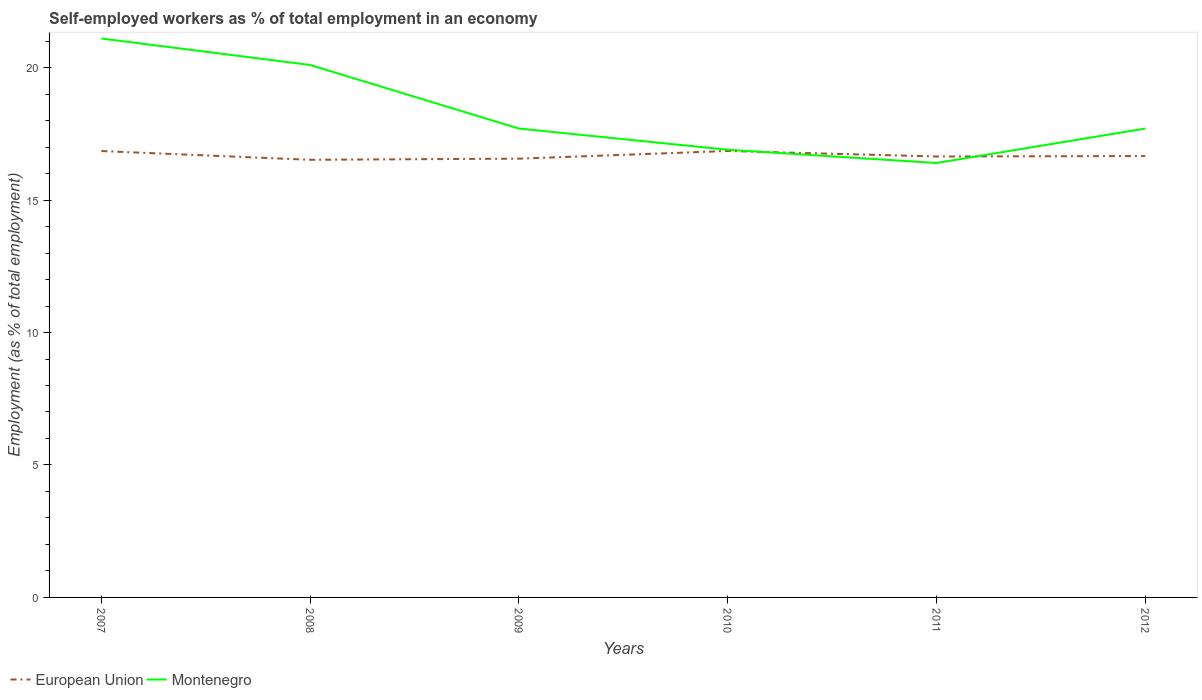Across all years, what is the maximum percentage of self-employed workers in Montenegro?
Your answer should be very brief. 16.4. In which year was the percentage of self-employed workers in European Union maximum?
Your response must be concise. 2008. What is the total percentage of self-employed workers in Montenegro in the graph?
Give a very brief answer. 2.4. What is the difference between the highest and the second highest percentage of self-employed workers in Montenegro?
Ensure brevity in your answer.  4.7. Is the percentage of self-employed workers in European Union strictly greater than the percentage of self-employed workers in Montenegro over the years?
Offer a very short reply. No. How many lines are there?
Offer a very short reply. 2. What is the difference between two consecutive major ticks on the Y-axis?
Make the answer very short. 5. Does the graph contain grids?
Your answer should be compact. No. How many legend labels are there?
Keep it short and to the point. 2. How are the legend labels stacked?
Provide a succinct answer. Horizontal. What is the title of the graph?
Keep it short and to the point. Self-employed workers as % of total employment in an economy. Does "Swaziland" appear as one of the legend labels in the graph?
Make the answer very short. No. What is the label or title of the X-axis?
Your answer should be compact. Years. What is the label or title of the Y-axis?
Your answer should be compact. Employment (as % of total employment). What is the Employment (as % of total employment) in European Union in 2007?
Your answer should be very brief. 16.85. What is the Employment (as % of total employment) in Montenegro in 2007?
Provide a short and direct response. 21.1. What is the Employment (as % of total employment) of European Union in 2008?
Your answer should be very brief. 16.52. What is the Employment (as % of total employment) of Montenegro in 2008?
Offer a very short reply. 20.1. What is the Employment (as % of total employment) of European Union in 2009?
Provide a succinct answer. 16.56. What is the Employment (as % of total employment) of Montenegro in 2009?
Your response must be concise. 17.7. What is the Employment (as % of total employment) in European Union in 2010?
Offer a terse response. 16.85. What is the Employment (as % of total employment) in Montenegro in 2010?
Your answer should be very brief. 16.9. What is the Employment (as % of total employment) of European Union in 2011?
Ensure brevity in your answer.  16.65. What is the Employment (as % of total employment) of Montenegro in 2011?
Your response must be concise. 16.4. What is the Employment (as % of total employment) of European Union in 2012?
Your answer should be compact. 16.66. What is the Employment (as % of total employment) in Montenegro in 2012?
Your answer should be compact. 17.7. Across all years, what is the maximum Employment (as % of total employment) of European Union?
Keep it short and to the point. 16.85. Across all years, what is the maximum Employment (as % of total employment) in Montenegro?
Provide a short and direct response. 21.1. Across all years, what is the minimum Employment (as % of total employment) of European Union?
Make the answer very short. 16.52. Across all years, what is the minimum Employment (as % of total employment) of Montenegro?
Ensure brevity in your answer.  16.4. What is the total Employment (as % of total employment) of European Union in the graph?
Make the answer very short. 100.09. What is the total Employment (as % of total employment) in Montenegro in the graph?
Provide a short and direct response. 109.9. What is the difference between the Employment (as % of total employment) in European Union in 2007 and that in 2008?
Your response must be concise. 0.33. What is the difference between the Employment (as % of total employment) in Montenegro in 2007 and that in 2008?
Your response must be concise. 1. What is the difference between the Employment (as % of total employment) in European Union in 2007 and that in 2009?
Offer a terse response. 0.29. What is the difference between the Employment (as % of total employment) in Montenegro in 2007 and that in 2009?
Your response must be concise. 3.4. What is the difference between the Employment (as % of total employment) of European Union in 2007 and that in 2010?
Make the answer very short. -0. What is the difference between the Employment (as % of total employment) of Montenegro in 2007 and that in 2010?
Your answer should be very brief. 4.2. What is the difference between the Employment (as % of total employment) of European Union in 2007 and that in 2011?
Make the answer very short. 0.21. What is the difference between the Employment (as % of total employment) of European Union in 2007 and that in 2012?
Give a very brief answer. 0.19. What is the difference between the Employment (as % of total employment) in Montenegro in 2007 and that in 2012?
Give a very brief answer. 3.4. What is the difference between the Employment (as % of total employment) of European Union in 2008 and that in 2009?
Provide a succinct answer. -0.04. What is the difference between the Employment (as % of total employment) of Montenegro in 2008 and that in 2009?
Ensure brevity in your answer.  2.4. What is the difference between the Employment (as % of total employment) of European Union in 2008 and that in 2010?
Keep it short and to the point. -0.33. What is the difference between the Employment (as % of total employment) in Montenegro in 2008 and that in 2010?
Provide a short and direct response. 3.2. What is the difference between the Employment (as % of total employment) of European Union in 2008 and that in 2011?
Make the answer very short. -0.12. What is the difference between the Employment (as % of total employment) in Montenegro in 2008 and that in 2011?
Your answer should be compact. 3.7. What is the difference between the Employment (as % of total employment) of European Union in 2008 and that in 2012?
Provide a short and direct response. -0.14. What is the difference between the Employment (as % of total employment) in Montenegro in 2008 and that in 2012?
Provide a short and direct response. 2.4. What is the difference between the Employment (as % of total employment) of European Union in 2009 and that in 2010?
Ensure brevity in your answer.  -0.29. What is the difference between the Employment (as % of total employment) in European Union in 2009 and that in 2011?
Offer a very short reply. -0.08. What is the difference between the Employment (as % of total employment) in European Union in 2009 and that in 2012?
Your answer should be very brief. -0.1. What is the difference between the Employment (as % of total employment) in European Union in 2010 and that in 2011?
Keep it short and to the point. 0.21. What is the difference between the Employment (as % of total employment) of European Union in 2010 and that in 2012?
Your response must be concise. 0.19. What is the difference between the Employment (as % of total employment) of Montenegro in 2010 and that in 2012?
Make the answer very short. -0.8. What is the difference between the Employment (as % of total employment) of European Union in 2011 and that in 2012?
Keep it short and to the point. -0.02. What is the difference between the Employment (as % of total employment) of Montenegro in 2011 and that in 2012?
Your answer should be compact. -1.3. What is the difference between the Employment (as % of total employment) of European Union in 2007 and the Employment (as % of total employment) of Montenegro in 2008?
Give a very brief answer. -3.25. What is the difference between the Employment (as % of total employment) of European Union in 2007 and the Employment (as % of total employment) of Montenegro in 2009?
Your answer should be very brief. -0.85. What is the difference between the Employment (as % of total employment) of European Union in 2007 and the Employment (as % of total employment) of Montenegro in 2010?
Your answer should be very brief. -0.05. What is the difference between the Employment (as % of total employment) of European Union in 2007 and the Employment (as % of total employment) of Montenegro in 2011?
Provide a short and direct response. 0.45. What is the difference between the Employment (as % of total employment) in European Union in 2007 and the Employment (as % of total employment) in Montenegro in 2012?
Provide a succinct answer. -0.85. What is the difference between the Employment (as % of total employment) of European Union in 2008 and the Employment (as % of total employment) of Montenegro in 2009?
Keep it short and to the point. -1.18. What is the difference between the Employment (as % of total employment) of European Union in 2008 and the Employment (as % of total employment) of Montenegro in 2010?
Provide a succinct answer. -0.38. What is the difference between the Employment (as % of total employment) of European Union in 2008 and the Employment (as % of total employment) of Montenegro in 2011?
Make the answer very short. 0.12. What is the difference between the Employment (as % of total employment) of European Union in 2008 and the Employment (as % of total employment) of Montenegro in 2012?
Offer a very short reply. -1.18. What is the difference between the Employment (as % of total employment) of European Union in 2009 and the Employment (as % of total employment) of Montenegro in 2010?
Make the answer very short. -0.34. What is the difference between the Employment (as % of total employment) in European Union in 2009 and the Employment (as % of total employment) in Montenegro in 2011?
Ensure brevity in your answer.  0.16. What is the difference between the Employment (as % of total employment) in European Union in 2009 and the Employment (as % of total employment) in Montenegro in 2012?
Your answer should be compact. -1.14. What is the difference between the Employment (as % of total employment) in European Union in 2010 and the Employment (as % of total employment) in Montenegro in 2011?
Make the answer very short. 0.45. What is the difference between the Employment (as % of total employment) in European Union in 2010 and the Employment (as % of total employment) in Montenegro in 2012?
Your response must be concise. -0.85. What is the difference between the Employment (as % of total employment) of European Union in 2011 and the Employment (as % of total employment) of Montenegro in 2012?
Your answer should be very brief. -1.05. What is the average Employment (as % of total employment) of European Union per year?
Provide a short and direct response. 16.68. What is the average Employment (as % of total employment) of Montenegro per year?
Provide a short and direct response. 18.32. In the year 2007, what is the difference between the Employment (as % of total employment) in European Union and Employment (as % of total employment) in Montenegro?
Your answer should be very brief. -4.25. In the year 2008, what is the difference between the Employment (as % of total employment) in European Union and Employment (as % of total employment) in Montenegro?
Offer a very short reply. -3.58. In the year 2009, what is the difference between the Employment (as % of total employment) in European Union and Employment (as % of total employment) in Montenegro?
Provide a short and direct response. -1.14. In the year 2010, what is the difference between the Employment (as % of total employment) in European Union and Employment (as % of total employment) in Montenegro?
Provide a short and direct response. -0.05. In the year 2011, what is the difference between the Employment (as % of total employment) in European Union and Employment (as % of total employment) in Montenegro?
Keep it short and to the point. 0.25. In the year 2012, what is the difference between the Employment (as % of total employment) of European Union and Employment (as % of total employment) of Montenegro?
Your response must be concise. -1.04. What is the ratio of the Employment (as % of total employment) in European Union in 2007 to that in 2008?
Keep it short and to the point. 1.02. What is the ratio of the Employment (as % of total employment) of Montenegro in 2007 to that in 2008?
Provide a succinct answer. 1.05. What is the ratio of the Employment (as % of total employment) of European Union in 2007 to that in 2009?
Your response must be concise. 1.02. What is the ratio of the Employment (as % of total employment) of Montenegro in 2007 to that in 2009?
Ensure brevity in your answer.  1.19. What is the ratio of the Employment (as % of total employment) in Montenegro in 2007 to that in 2010?
Your answer should be very brief. 1.25. What is the ratio of the Employment (as % of total employment) of European Union in 2007 to that in 2011?
Your response must be concise. 1.01. What is the ratio of the Employment (as % of total employment) of Montenegro in 2007 to that in 2011?
Make the answer very short. 1.29. What is the ratio of the Employment (as % of total employment) in European Union in 2007 to that in 2012?
Your answer should be compact. 1.01. What is the ratio of the Employment (as % of total employment) in Montenegro in 2007 to that in 2012?
Your answer should be very brief. 1.19. What is the ratio of the Employment (as % of total employment) of Montenegro in 2008 to that in 2009?
Give a very brief answer. 1.14. What is the ratio of the Employment (as % of total employment) of European Union in 2008 to that in 2010?
Your answer should be very brief. 0.98. What is the ratio of the Employment (as % of total employment) in Montenegro in 2008 to that in 2010?
Provide a short and direct response. 1.19. What is the ratio of the Employment (as % of total employment) in Montenegro in 2008 to that in 2011?
Ensure brevity in your answer.  1.23. What is the ratio of the Employment (as % of total employment) of Montenegro in 2008 to that in 2012?
Your answer should be very brief. 1.14. What is the ratio of the Employment (as % of total employment) in European Union in 2009 to that in 2010?
Provide a short and direct response. 0.98. What is the ratio of the Employment (as % of total employment) of Montenegro in 2009 to that in 2010?
Keep it short and to the point. 1.05. What is the ratio of the Employment (as % of total employment) of European Union in 2009 to that in 2011?
Your answer should be compact. 1. What is the ratio of the Employment (as % of total employment) in Montenegro in 2009 to that in 2011?
Offer a very short reply. 1.08. What is the ratio of the Employment (as % of total employment) of European Union in 2009 to that in 2012?
Give a very brief answer. 0.99. What is the ratio of the Employment (as % of total employment) in Montenegro in 2009 to that in 2012?
Give a very brief answer. 1. What is the ratio of the Employment (as % of total employment) of European Union in 2010 to that in 2011?
Your answer should be compact. 1.01. What is the ratio of the Employment (as % of total employment) of Montenegro in 2010 to that in 2011?
Give a very brief answer. 1.03. What is the ratio of the Employment (as % of total employment) in European Union in 2010 to that in 2012?
Your response must be concise. 1.01. What is the ratio of the Employment (as % of total employment) of Montenegro in 2010 to that in 2012?
Your answer should be compact. 0.95. What is the ratio of the Employment (as % of total employment) of Montenegro in 2011 to that in 2012?
Offer a terse response. 0.93. What is the difference between the highest and the second highest Employment (as % of total employment) in European Union?
Your response must be concise. 0. What is the difference between the highest and the lowest Employment (as % of total employment) of European Union?
Your answer should be very brief. 0.33. 